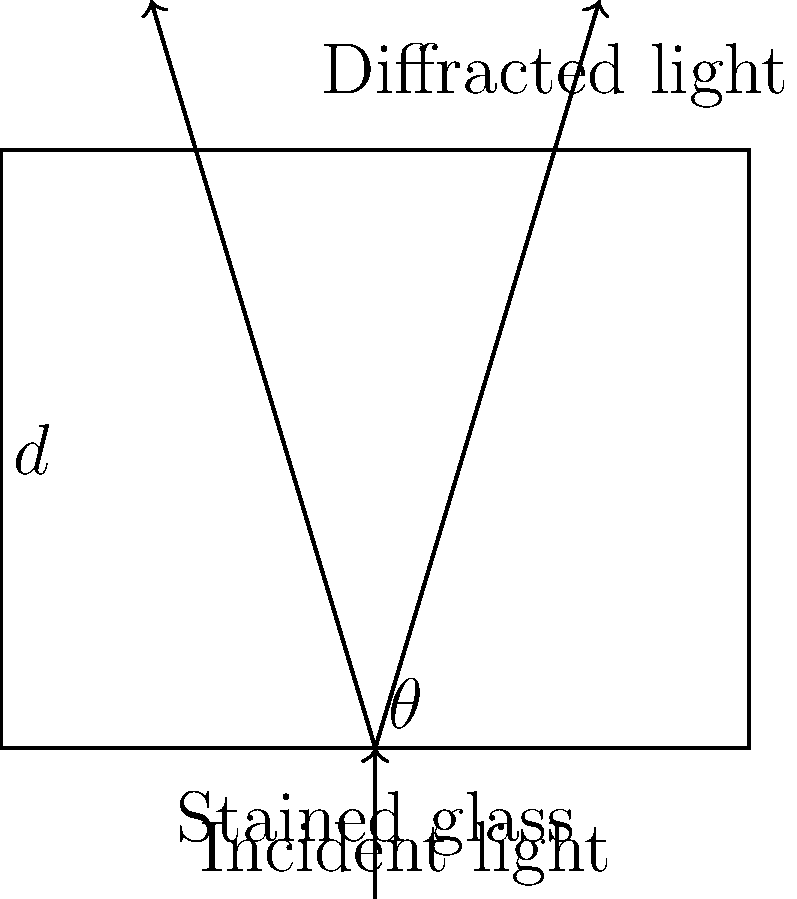In a Gothic cathedral, a stained glass window acts as a diffraction grating for incident light. The window's intricate pattern creates slits with a separation of $d = 5 \times 10^{-6}$ m. If light with a wavelength of $\lambda = 550$ nm falls perpendicularly on the window, at what angle $\theta$ will the first-order maximum of diffracted light be observed? Consider how this ethereal display might symbolize the fragmentation of the human spirit in Victorian literature. To solve this problem, we'll use the diffraction grating equation for the first-order maximum:

1. The diffraction grating equation is:
   $d \sin \theta = m\lambda$

   Where:
   $d$ is the slit separation
   $\theta$ is the angle of diffraction
   $m$ is the order of diffraction (in this case, 1)
   $\lambda$ is the wavelength of light

2. We're given:
   $d = 5 \times 10^{-6}$ m
   $\lambda = 550$ nm = $5.5 \times 10^{-7}$ m
   $m = 1$ (first-order maximum)

3. Substituting these values into the equation:
   $(5 \times 10^{-6}) \sin \theta = 1(5.5 \times 10^{-7})$

4. Simplify:
   $5 \sin \theta = 0.55$

5. Solve for $\theta$:
   $\sin \theta = 0.11$
   $\theta = \arcsin(0.11)$

6. Calculate the final answer:
   $\theta \approx 6.31°$

This angle represents where the first-order maximum of diffracted light will appear, creating a hauntingly beautiful display reminiscent of the fragmented narratives in Victorian Gothic literature.
Answer: $6.31°$ 